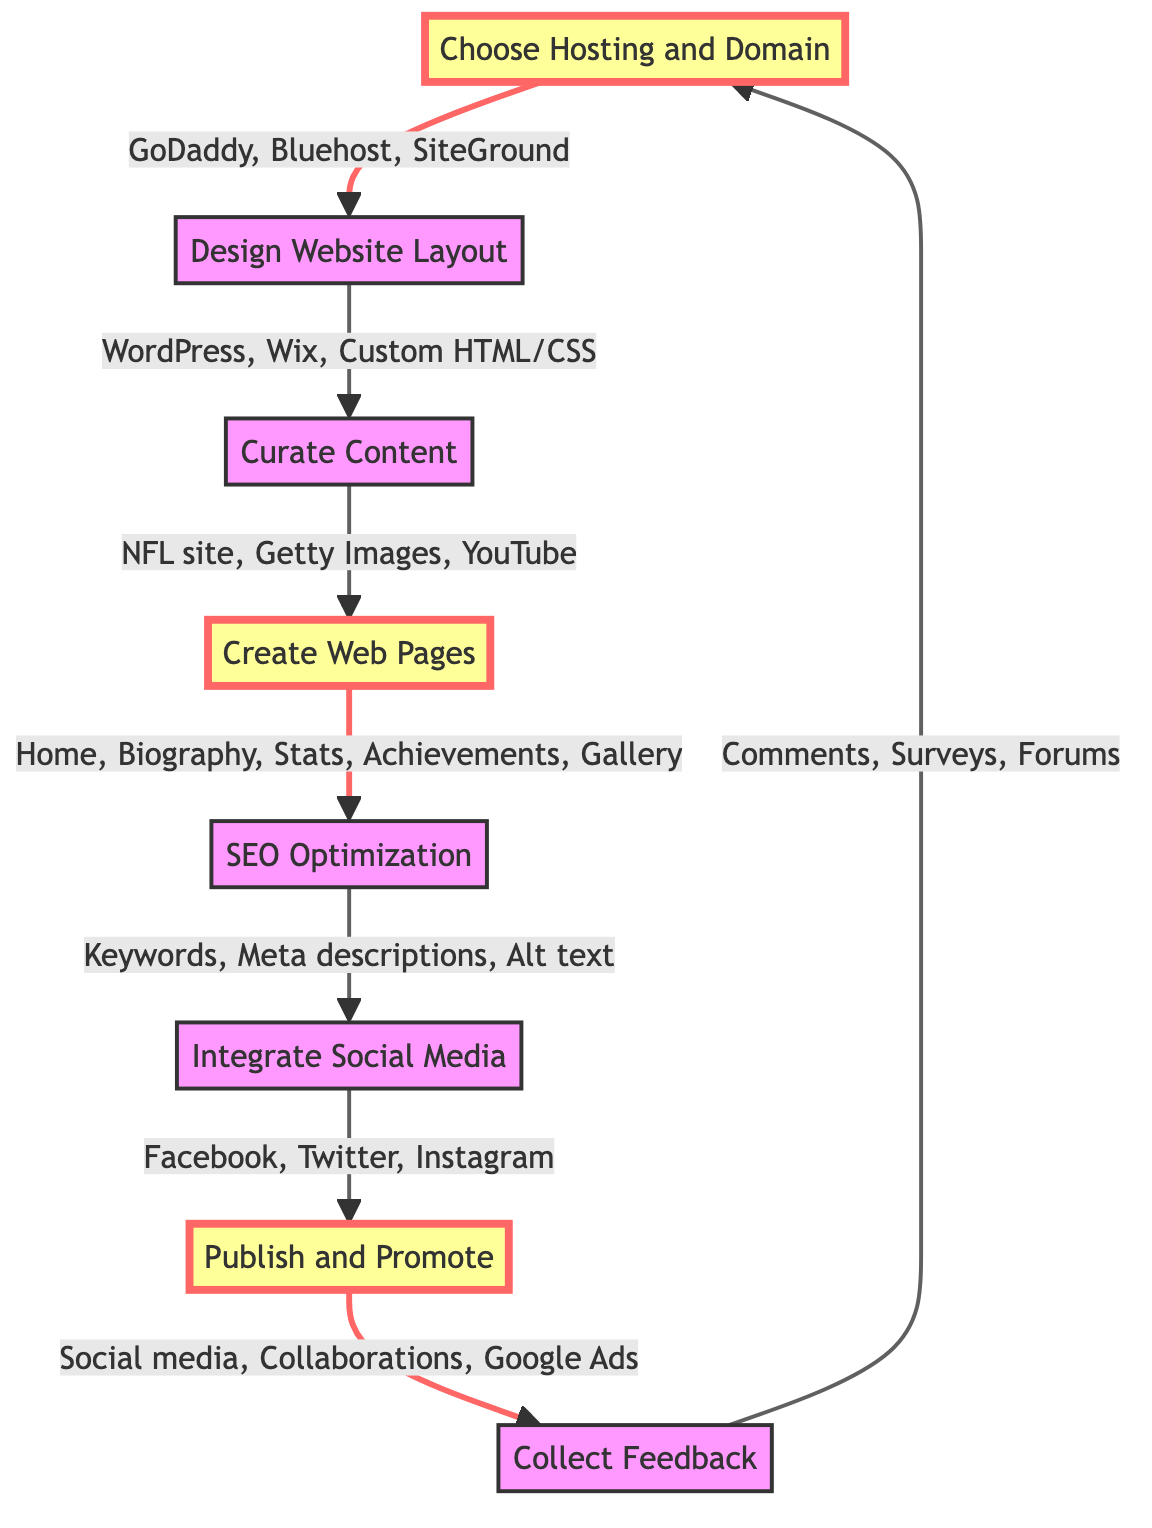What is the first step in creating a Tom Brady tribute website? The first step in the flow chart is "Choose Hosting and Domain". This is found at the topmost part of the diagram, indicating it is the starting point of the process.
Answer: Choose Hosting and Domain How many main steps are there in the diagram? By counting the distinct steps from "Choose Hosting and Domain" to "Collect Feedback", there are a total of 8 main steps outlined in the flow chart.
Answer: 8 What are the examples provided for the step "Design Website Layout"? In the 'Design Website Layout' node, there are three examples listed: "WordPress", "Wix", and "Custom HTML/CSS". These are found directly branching from the 'Design Website Layout' step.
Answer: WordPress, Wix, Custom HTML/CSS Which step comes immediately after "SEO Optimization"? The step that follows "SEO Optimization" in the sequence of the diagram is "Integrate Social Media". This can be traced from the connection leading from "SEO Optimization" to "Integrate Social Media".
Answer: Integrate Social Media What is the last step before "Collect Feedback"? The last step before reaching "Collect Feedback" is "Publish and Promote". This step directly leads into the feedback collection process as represented in the flow chart.
Answer: Publish and Promote What types of channels are suggested for promoting the website? The 'Publish and Promote' step includes various types of promotional channels listed: "Social media marketing", "Collaborate with other sports fan sites", and "Use Google Ads". These are examples provided for enhancing the site's visibility.
Answer: Social media marketing, Collaborate with other sports fan sites, Use Google Ads What is the relationship between "Create Web Pages" and "Curate Content"? The relationship is sequential; "Curate Content" must be completed before progressing to "Create Web Pages". This relationship is established by the directional arrow showing the flow of tasks in the diagram.
Answer: Sequential relationship How does the diagram suggest gathering feedback from fans? The 'Collect Feedback' step suggests engagement through "Comment sections", "Surveys", and "Fan forums". These are listed as methods for collecting fan input, demonstrating interaction and improvements.
Answer: Comment sections, Surveys, Fan forums 